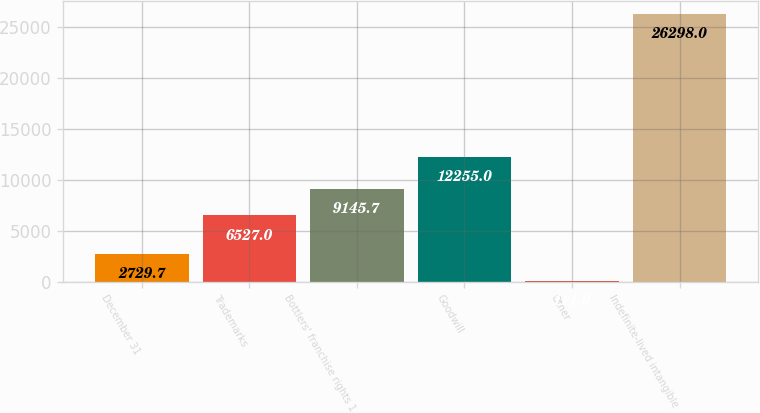Convert chart. <chart><loc_0><loc_0><loc_500><loc_500><bar_chart><fcel>December 31<fcel>Trademarks<fcel>Bottlers' franchise rights 1<fcel>Goodwill<fcel>Other<fcel>Indefinite-lived intangible<nl><fcel>2729.7<fcel>6527<fcel>9145.7<fcel>12255<fcel>111<fcel>26298<nl></chart> 